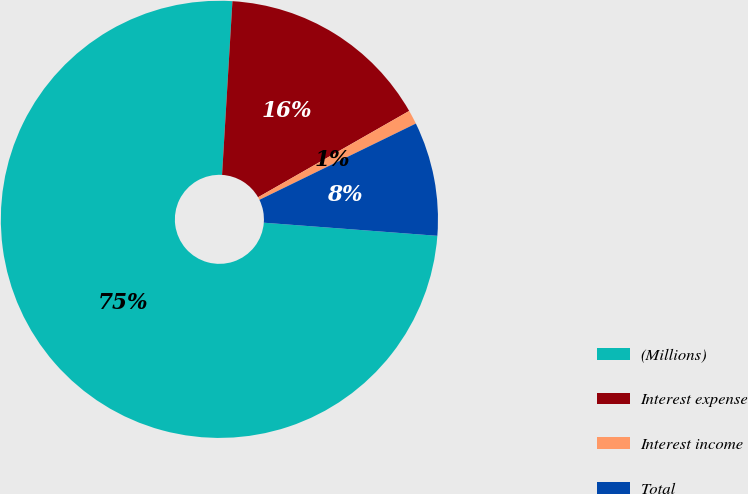Convert chart to OTSL. <chart><loc_0><loc_0><loc_500><loc_500><pie_chart><fcel>(Millions)<fcel>Interest expense<fcel>Interest income<fcel>Total<nl><fcel>74.75%<fcel>15.79%<fcel>1.04%<fcel>8.42%<nl></chart> 